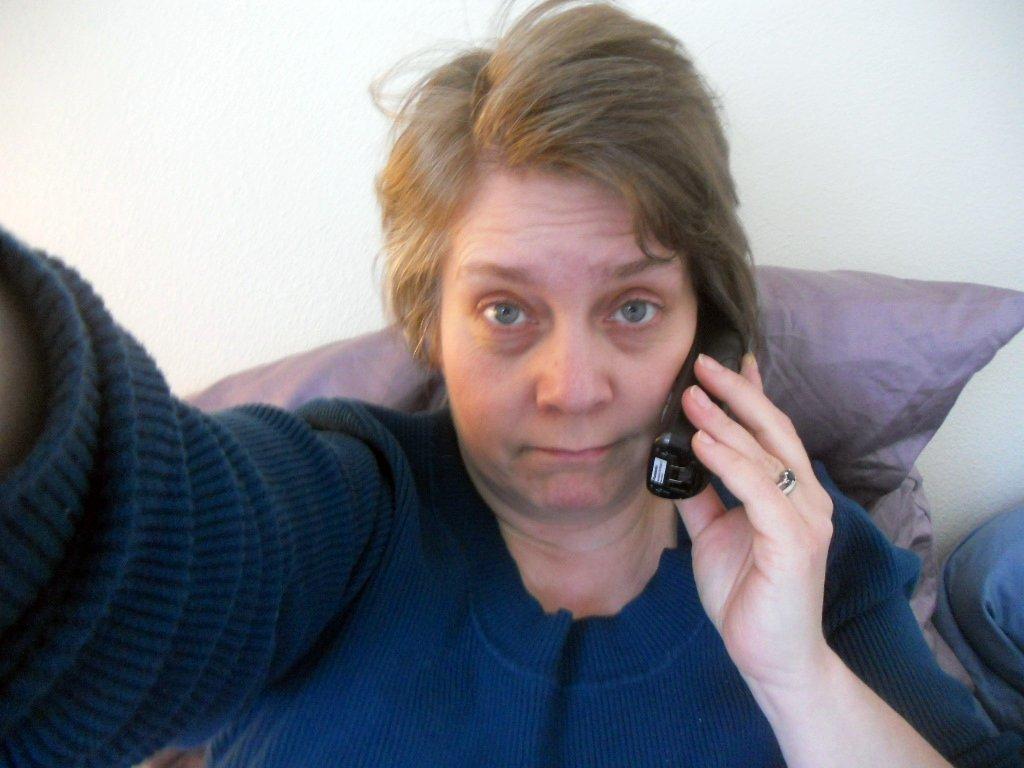Could you give a brief overview of what you see in this image? In the image we can see a woman wearing clothes and finger ring. She is holding a mobile phone in her hand. There are the pillows and a wall. 